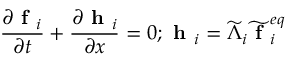Convert formula to latex. <formula><loc_0><loc_0><loc_500><loc_500>\frac { \partial f _ { i } } { \partial t } + \frac { \partial h _ { i } } { \partial x } = 0 ; h _ { i } = \widetilde { \Lambda } _ { i } \widetilde { f } _ { i } ^ { e q }</formula> 